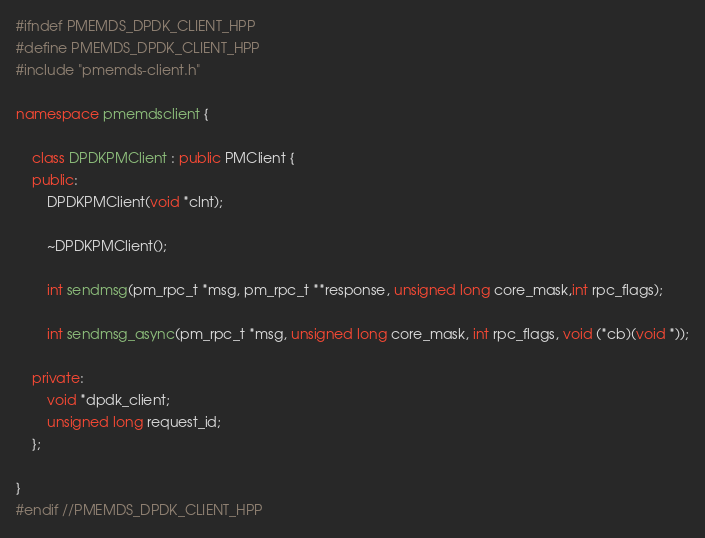Convert code to text. <code><loc_0><loc_0><loc_500><loc_500><_C++_>#ifndef PMEMDS_DPDK_CLIENT_HPP
#define PMEMDS_DPDK_CLIENT_HPP
#include "pmemds-client.h"

namespace pmemdsclient {

    class DPDKPMClient : public PMClient {
    public:
        DPDKPMClient(void *clnt);

        ~DPDKPMClient();

        int sendmsg(pm_rpc_t *msg, pm_rpc_t **response, unsigned long core_mask,int rpc_flags);

        int sendmsg_async(pm_rpc_t *msg, unsigned long core_mask, int rpc_flags, void (*cb)(void *));

    private:
        void *dpdk_client;
        unsigned long request_id;
    };

}
#endif //PMEMDS_DPDK_CLIENT_HPP
</code> 